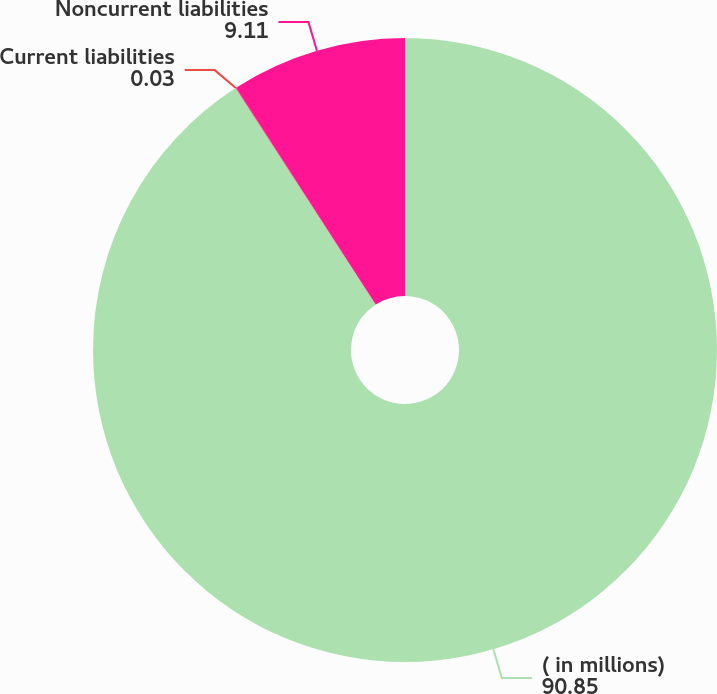<chart> <loc_0><loc_0><loc_500><loc_500><pie_chart><fcel>( in millions)<fcel>Current liabilities<fcel>Noncurrent liabilities<nl><fcel>90.85%<fcel>0.03%<fcel>9.11%<nl></chart> 